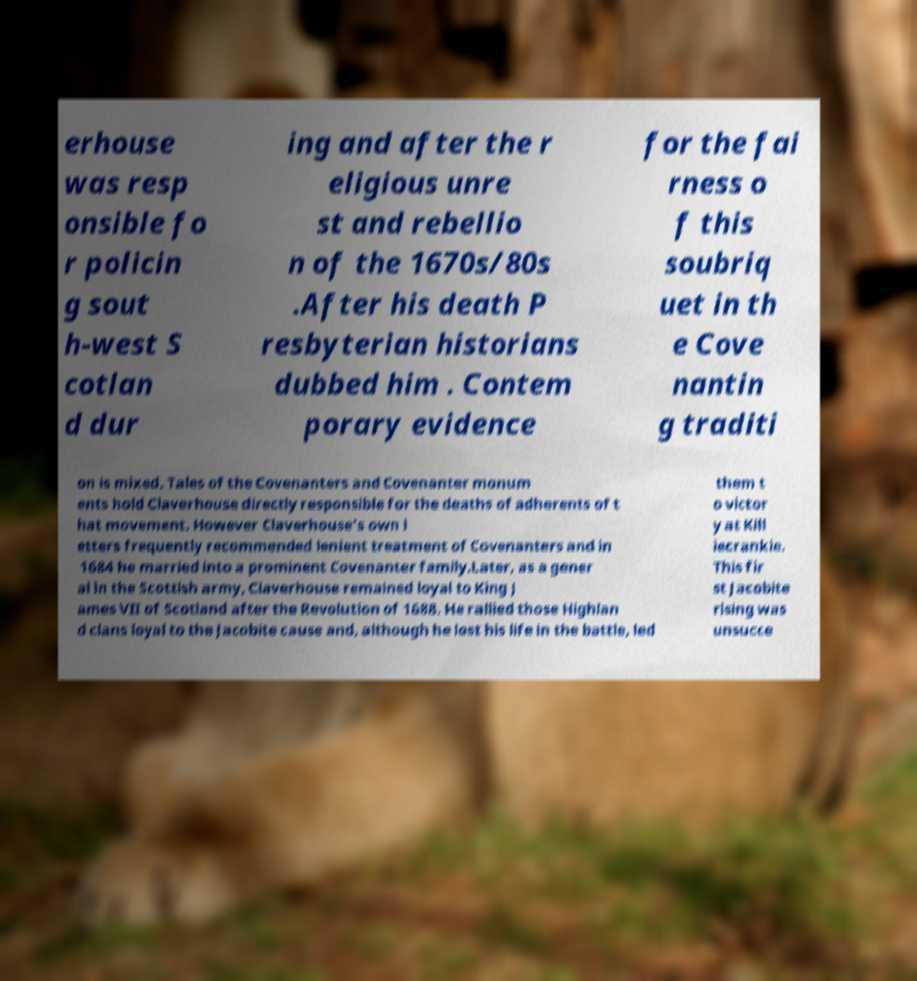What messages or text are displayed in this image? I need them in a readable, typed format. erhouse was resp onsible fo r policin g sout h-west S cotlan d dur ing and after the r eligious unre st and rebellio n of the 1670s/80s .After his death P resbyterian historians dubbed him . Contem porary evidence for the fai rness o f this soubriq uet in th e Cove nantin g traditi on is mixed. Tales of the Covenanters and Covenanter monum ents hold Claverhouse directly responsible for the deaths of adherents of t hat movement. However Claverhouse's own l etters frequently recommended lenient treatment of Covenanters and in 1684 he married into a prominent Covenanter family.Later, as a gener al in the Scottish army, Claverhouse remained loyal to King J ames VII of Scotland after the Revolution of 1688. He rallied those Highlan d clans loyal to the Jacobite cause and, although he lost his life in the battle, led them t o victor y at Kill iecrankie. This fir st Jacobite rising was unsucce 